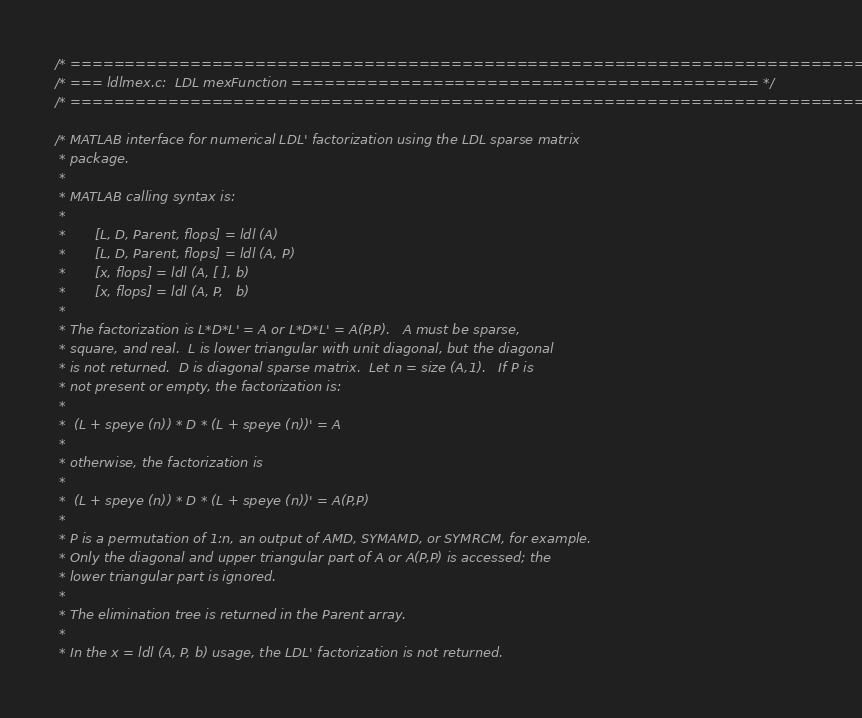<code> <loc_0><loc_0><loc_500><loc_500><_C_>/* ========================================================================== */
/* === ldlmex.c:  LDL mexFunction =========================================== */
/* ========================================================================== */

/* MATLAB interface for numerical LDL' factorization using the LDL sparse matrix
 * package.
 *
 * MATLAB calling syntax is:
 *
 *       [L, D, Parent, flops] = ldl (A)
 *       [L, D, Parent, flops] = ldl (A, P)
 *       [x, flops] = ldl (A, [ ], b)
 *       [x, flops] = ldl (A, P,   b)
 *
 * The factorization is L*D*L' = A or L*D*L' = A(P,P).   A must be sparse,
 * square, and real.  L is lower triangular with unit diagonal, but the diagonal
 * is not returned.  D is diagonal sparse matrix.  Let n = size (A,1).   If P is
 * not present or empty, the factorization is:
 *
 *	(L + speye (n)) * D * (L + speye (n))' = A
 *
 * otherwise, the factorization is
 *
 *	(L + speye (n)) * D * (L + speye (n))' = A(P,P)
 *
 * P is a permutation of 1:n, an output of AMD, SYMAMD, or SYMRCM, for example.
 * Only the diagonal and upper triangular part of A or A(P,P) is accessed; the
 * lower triangular part is ignored.
 *
 * The elimination tree is returned in the Parent array.
 *
 * In the x = ldl (A, P, b) usage, the LDL' factorization is not returned.</code> 